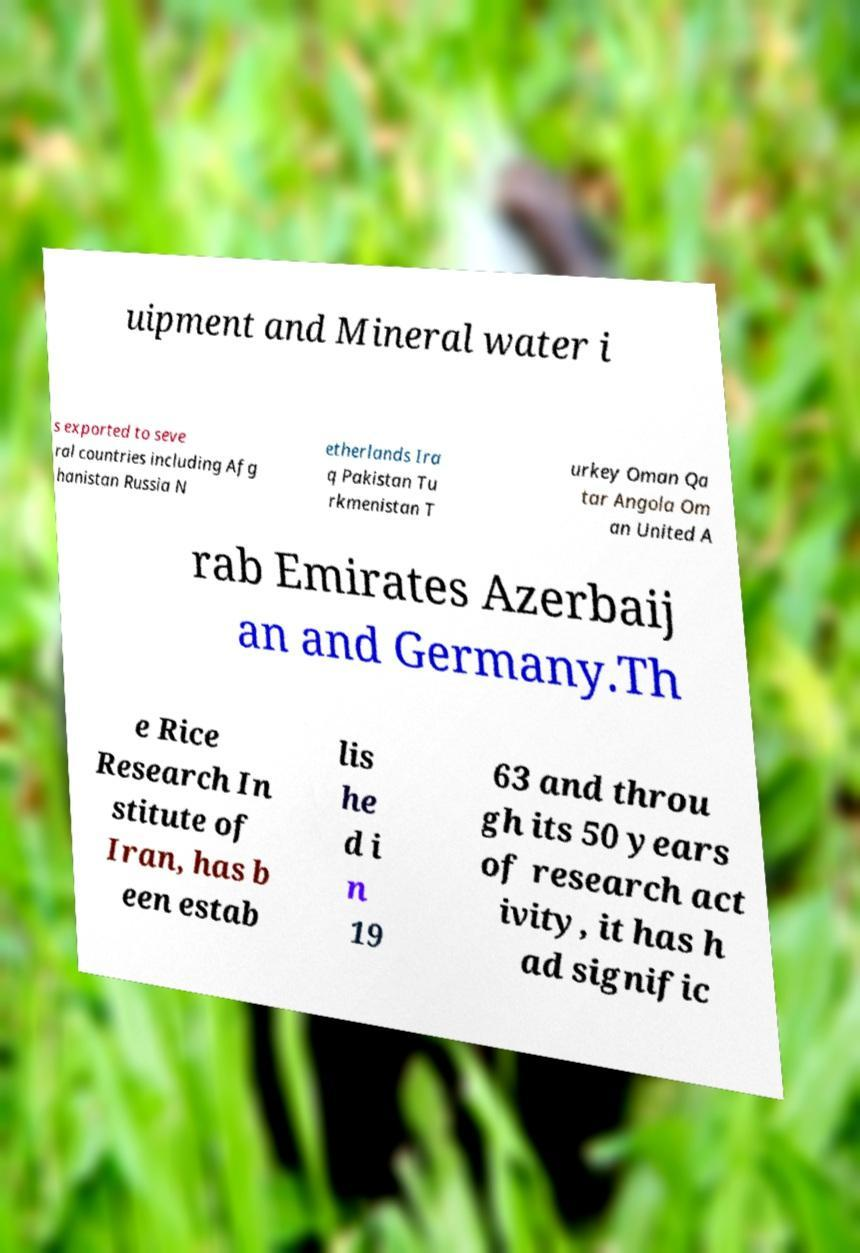Can you read and provide the text displayed in the image?This photo seems to have some interesting text. Can you extract and type it out for me? uipment and Mineral water i s exported to seve ral countries including Afg hanistan Russia N etherlands Ira q Pakistan Tu rkmenistan T urkey Oman Qa tar Angola Om an United A rab Emirates Azerbaij an and Germany.Th e Rice Research In stitute of Iran, has b een estab lis he d i n 19 63 and throu gh its 50 years of research act ivity, it has h ad signific 